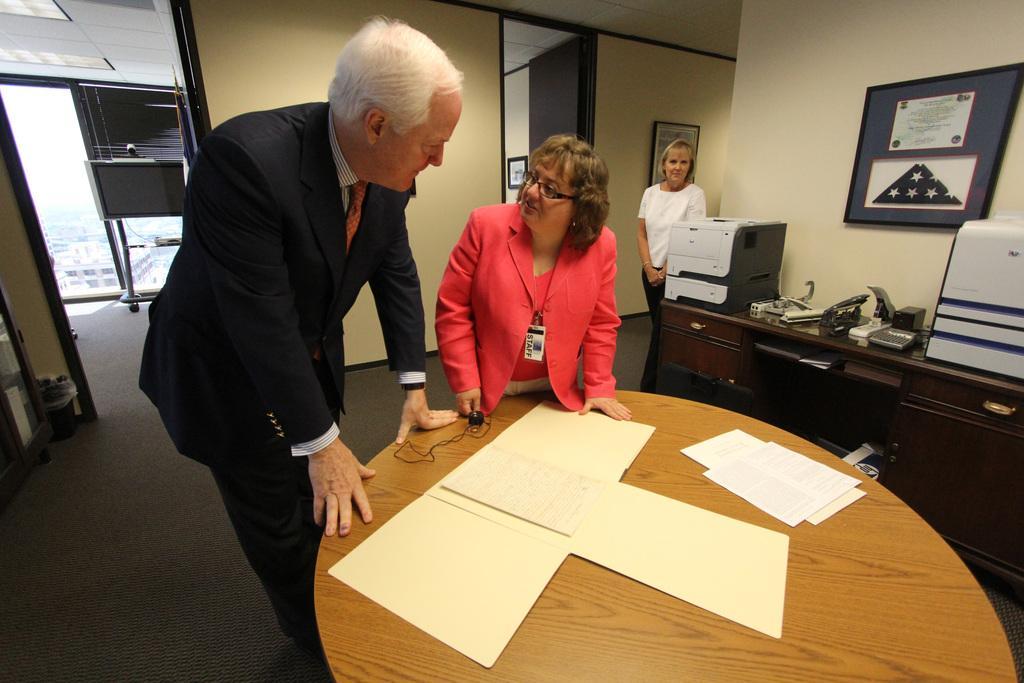Can you describe this image briefly? In this image i can see a man and a woman standing and talking at the right there is other woman standing, there are few papers on a table, at the back ground i can see a frame attached to a wall. 